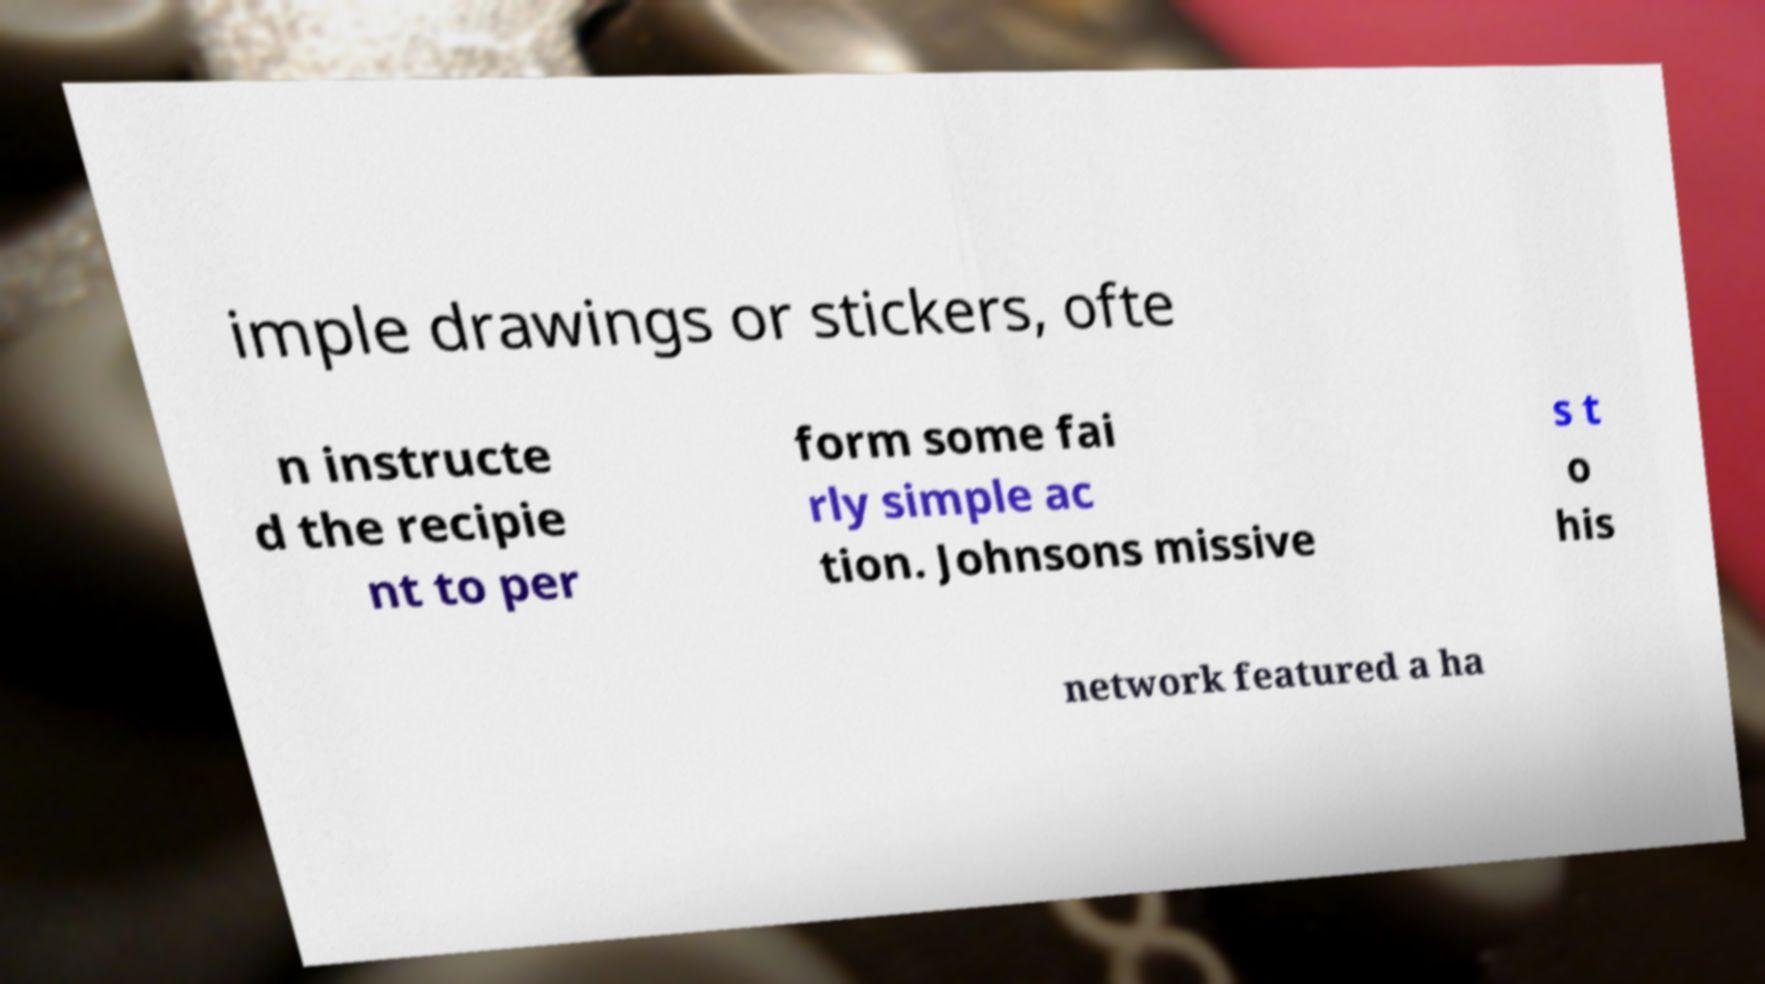Please read and relay the text visible in this image. What does it say? imple drawings or stickers, ofte n instructe d the recipie nt to per form some fai rly simple ac tion. Johnsons missive s t o his network featured a ha 